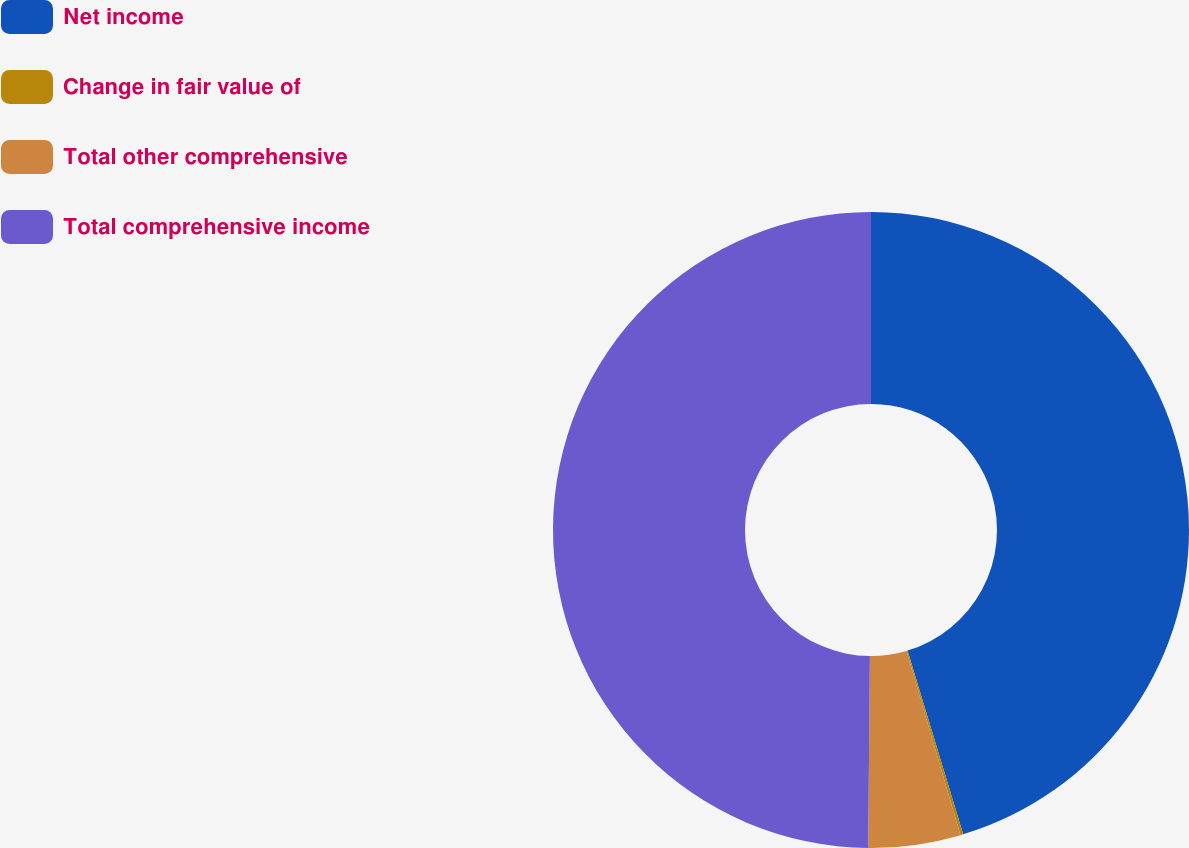Convert chart. <chart><loc_0><loc_0><loc_500><loc_500><pie_chart><fcel>Net income<fcel>Change in fair value of<fcel>Total other comprehensive<fcel>Total comprehensive income<nl><fcel>45.32%<fcel>0.14%<fcel>4.68%<fcel>49.86%<nl></chart> 